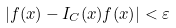Convert formula to latex. <formula><loc_0><loc_0><loc_500><loc_500>| f ( x ) - I _ { C } ( x ) f ( x ) | < \varepsilon</formula> 